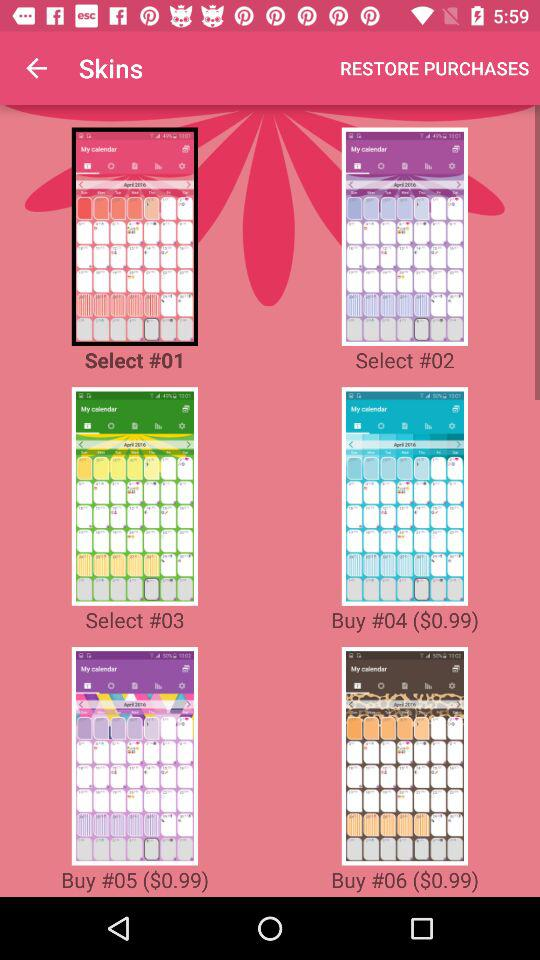What is the price of "#06"? The price is $0.99. 